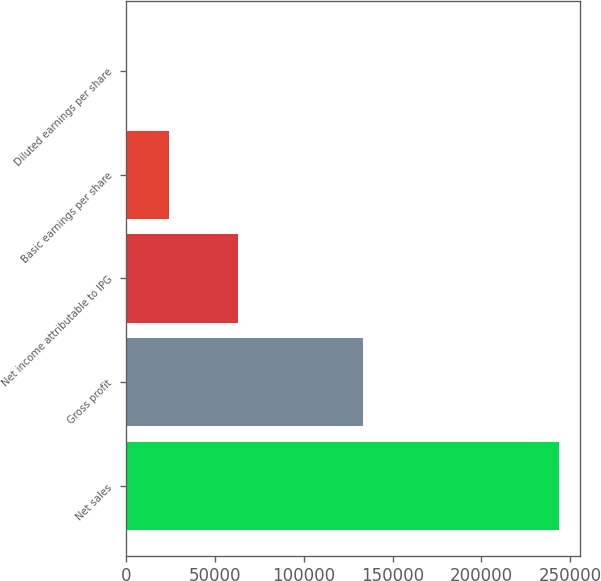<chart> <loc_0><loc_0><loc_500><loc_500><bar_chart><fcel>Net sales<fcel>Gross profit<fcel>Net income attributable to IPG<fcel>Basic earnings per share<fcel>Diluted earnings per share<nl><fcel>243541<fcel>133304<fcel>62792<fcel>24355.2<fcel>1.18<nl></chart> 